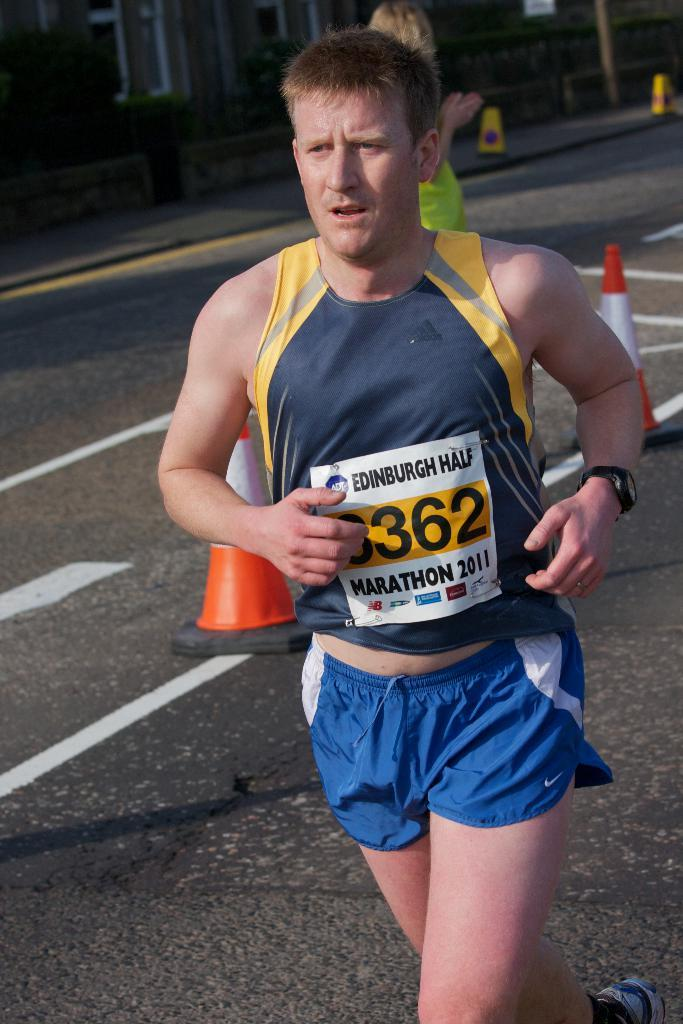<image>
Create a compact narrative representing the image presented. A man running while wearing a tag that says "Edinburgh Half Marathon 2011". 